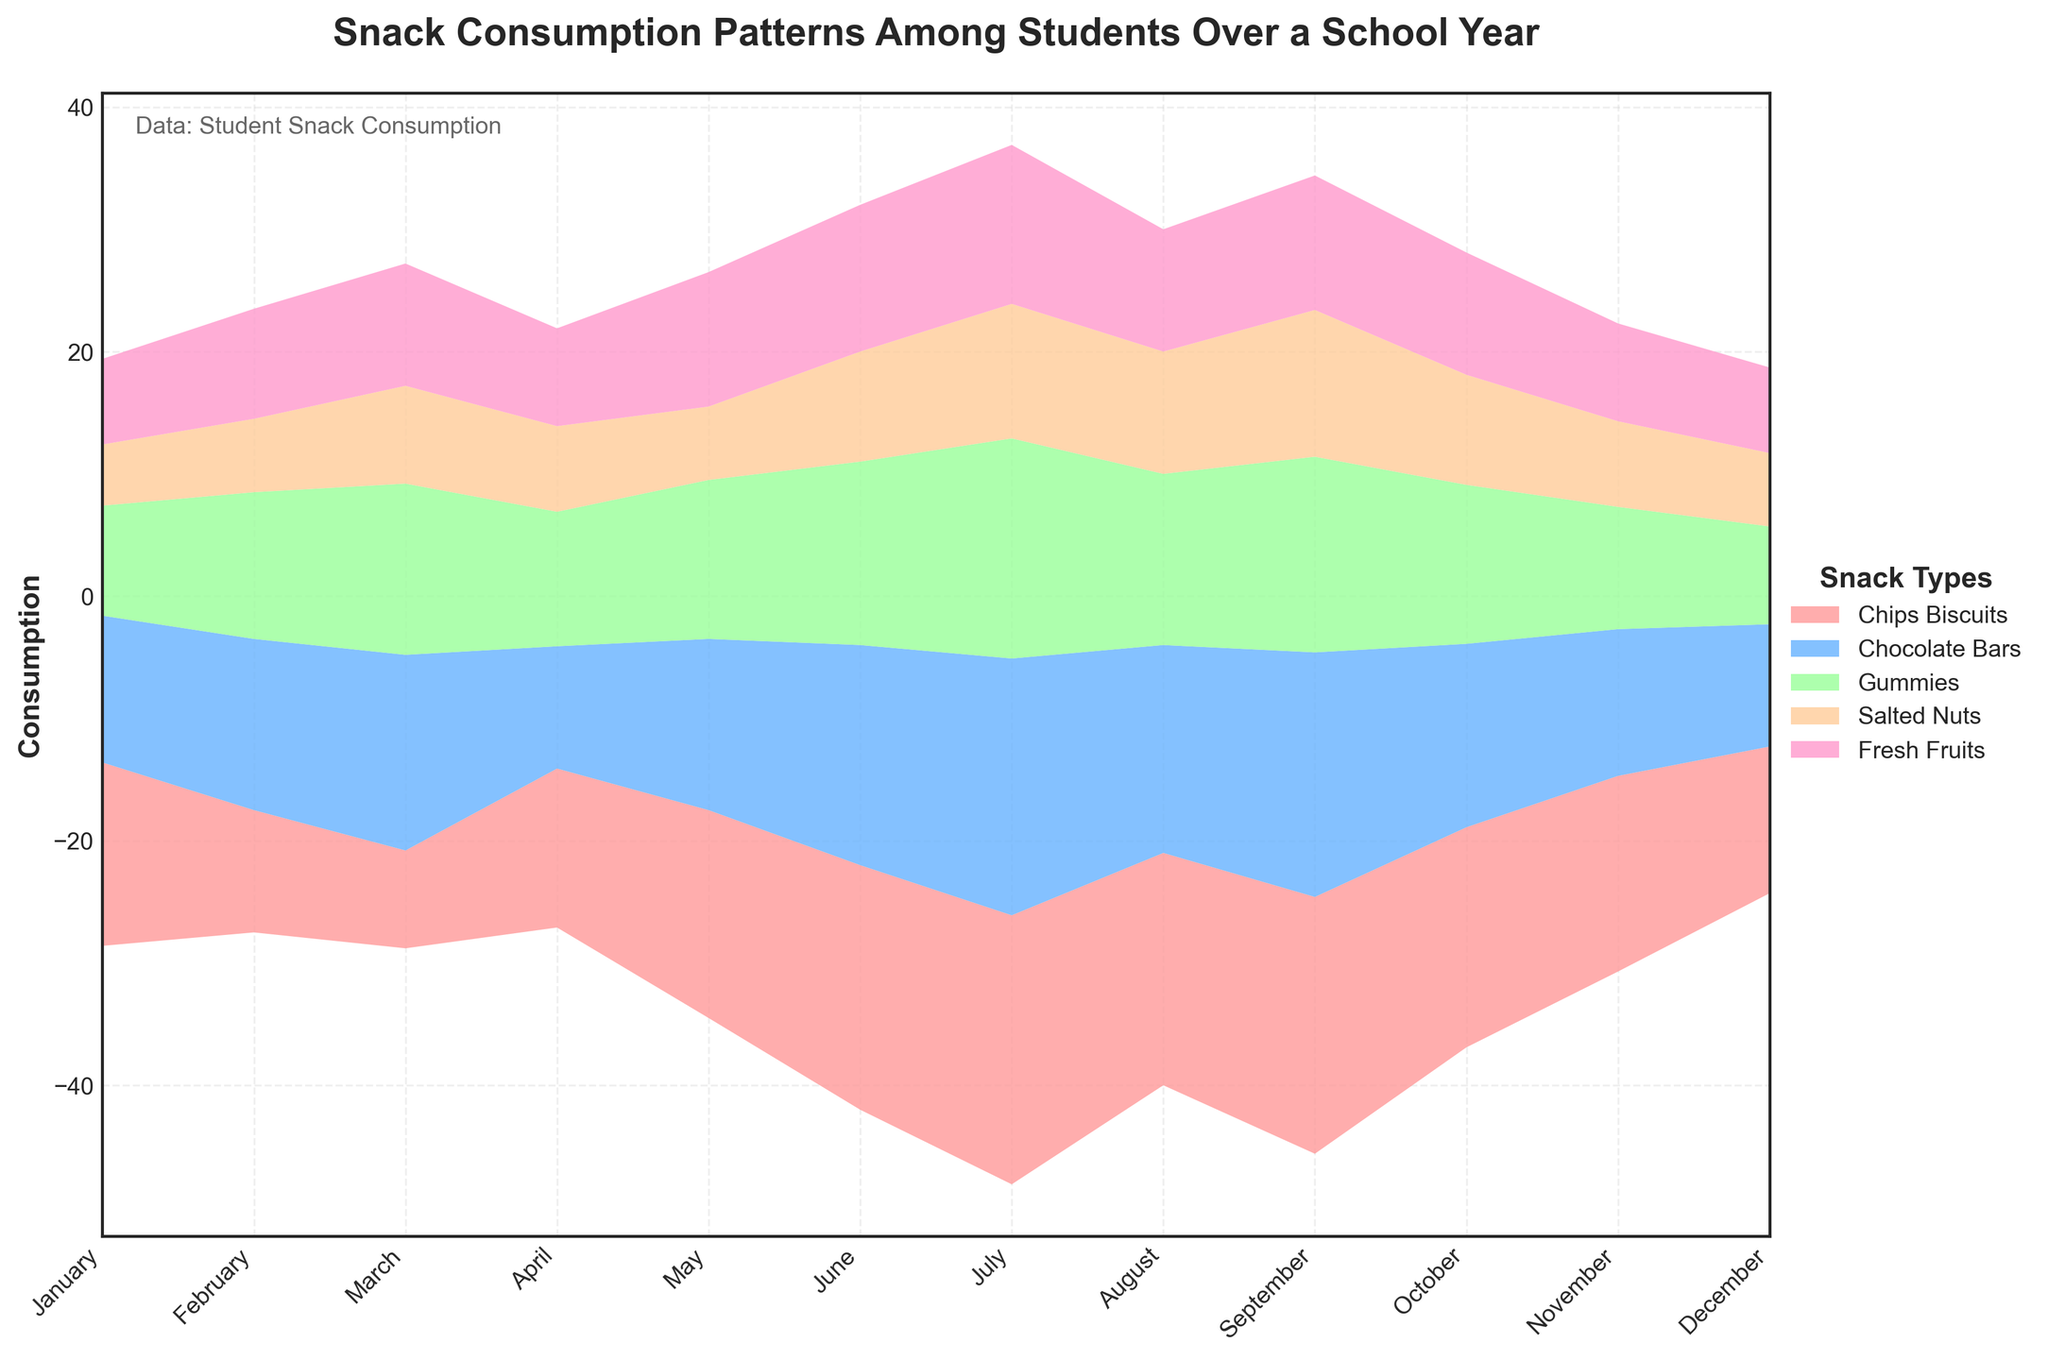What is the title of the stream graph? The title is typically displayed at the top of the graph. It usually gives an overview of what the graph is about. By looking at the top, we see "Snack Consumption Patterns Among Students Over a School Year".
Answer: Snack Consumption Patterns Among Students Over a School Year Which snack type has the highest consumption peak and during which month does it occur? By visually inspecting the stack layers, the highest peak is noticeable. We check each snack type and find that "Chips Biscuits" reaches its highest consumption in July.
Answer: Chips Biscuits in July During which month is the consumption of Fresh Fruits the highest? We follow the "Fresh Fruits" layer across the months. The highest point of this layer isn't buried and is clearly visible in July.
Answer: July List the months where the consumption of Chocolate Bars stays consistently high (15 or more units). Check the "Chocolate Bars" layer along the x-axis. We identify March (16), June (18), July (21), August (17), and September (20) as the months where consumption is 15 or more units.
Answer: March, June, July, August, September Compare the consumption patterns of Gummies and Salted Nuts in September. Which snack was consumed more? Look at the September vertical line and compare the layers of Gummies and Salted Nuts. Gummies reach up to 16 units, while Salted Nuts reach 12 units. Thus, Gummies were consumed more.
Answer: Gummies Calculate the average monthly consumption of Salted Nuts over the entire school year. Sum the Salted Nuts values: 5+6+8+7+6+9+11+10+12+9+7+6 = 96. Divide by the number of months: 96/12 = 8.
Answer: 8 What is the total combined consumption of all snacks in January? Sum the values for January: Chips Biscuits (15) + Chocolate Bars (12) + Gummies (9) + Salted Nuts (5) + Fresh Fruits (7) = 48.
Answer: 48 Identify the month(s) where the consumption of Gummies and Fresh Fruits are equal. Follow the Gummies and Fresh Fruits layers across all months to identify where they overlap. In February, both are at 9 units each.
Answer: February In which month did Chips Biscuits experience a sudden decrease in consumption compared to the previous month? Check the Chips Biscuits layer by month and spot any sudden decreases. From September (21) to October (18) is the most noticeable drop.
Answer: October 